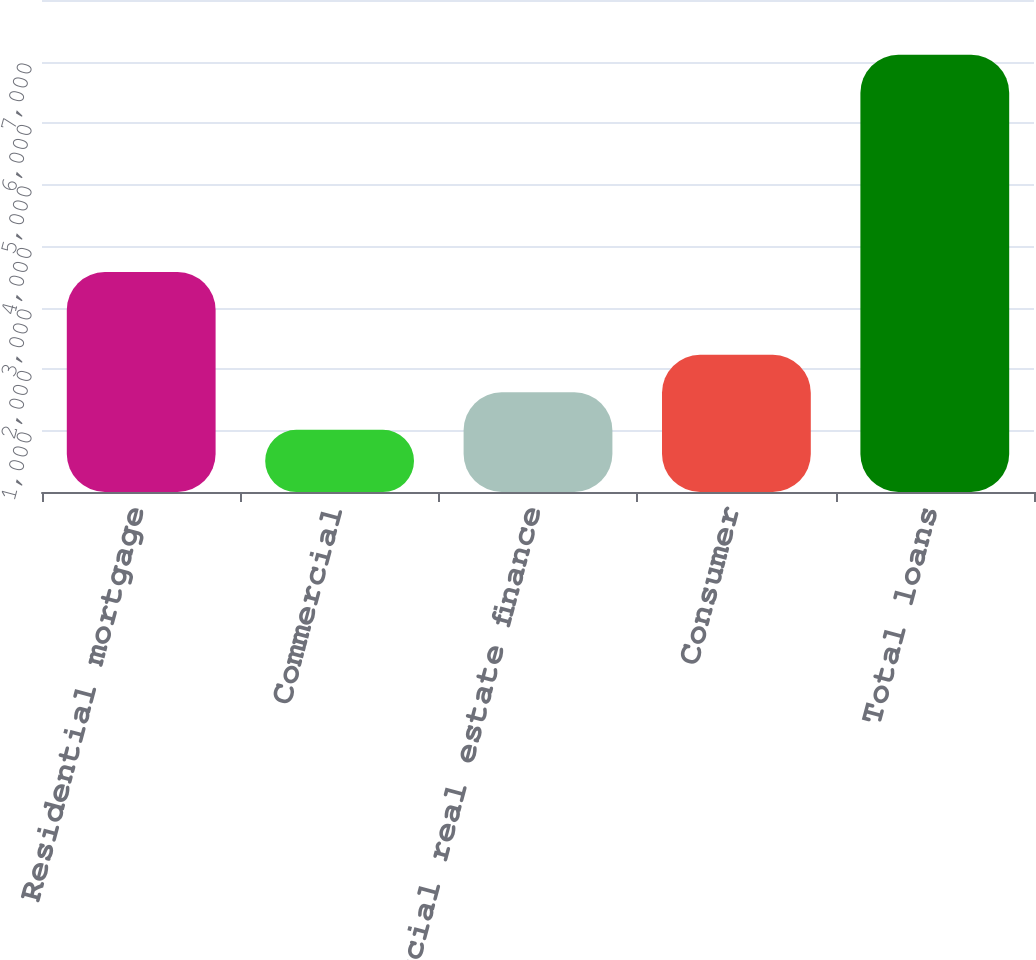Convert chart to OTSL. <chart><loc_0><loc_0><loc_500><loc_500><bar_chart><fcel>Residential mortgage<fcel>Commercial<fcel>Commercial real estate finance<fcel>Consumer<fcel>Total loans<nl><fcel>3576.7<fcel>1010.6<fcel>1620.39<fcel>2230.18<fcel>7108.5<nl></chart> 